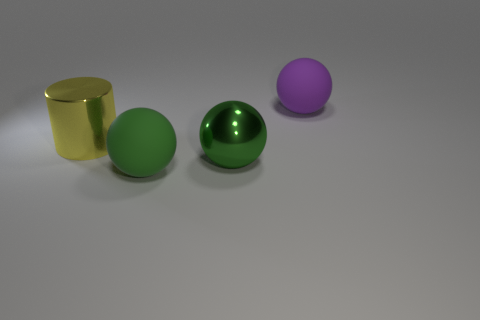What is the size of the yellow object that is behind the rubber object that is in front of the large yellow cylinder?
Your answer should be compact. Large. What is the thing that is behind the big yellow metal thing made of?
Your answer should be compact. Rubber. How many green matte objects are the same shape as the green shiny thing?
Your answer should be very brief. 1. Is the shape of the green matte thing the same as the large object behind the metallic cylinder?
Keep it short and to the point. Yes. There is a rubber thing that is the same color as the shiny ball; what is its shape?
Offer a very short reply. Sphere. Are there any large green things made of the same material as the big purple object?
Give a very brief answer. Yes. There is a purple ball to the right of the matte sphere in front of the large purple ball; what is its material?
Your answer should be very brief. Rubber. How many other objects are the same shape as the purple rubber object?
Your answer should be compact. 2. Does the big rubber sphere in front of the big purple object have the same color as the metallic thing right of the yellow metal object?
Keep it short and to the point. Yes. What color is the shiny thing that is the same size as the green metallic sphere?
Provide a succinct answer. Yellow. 